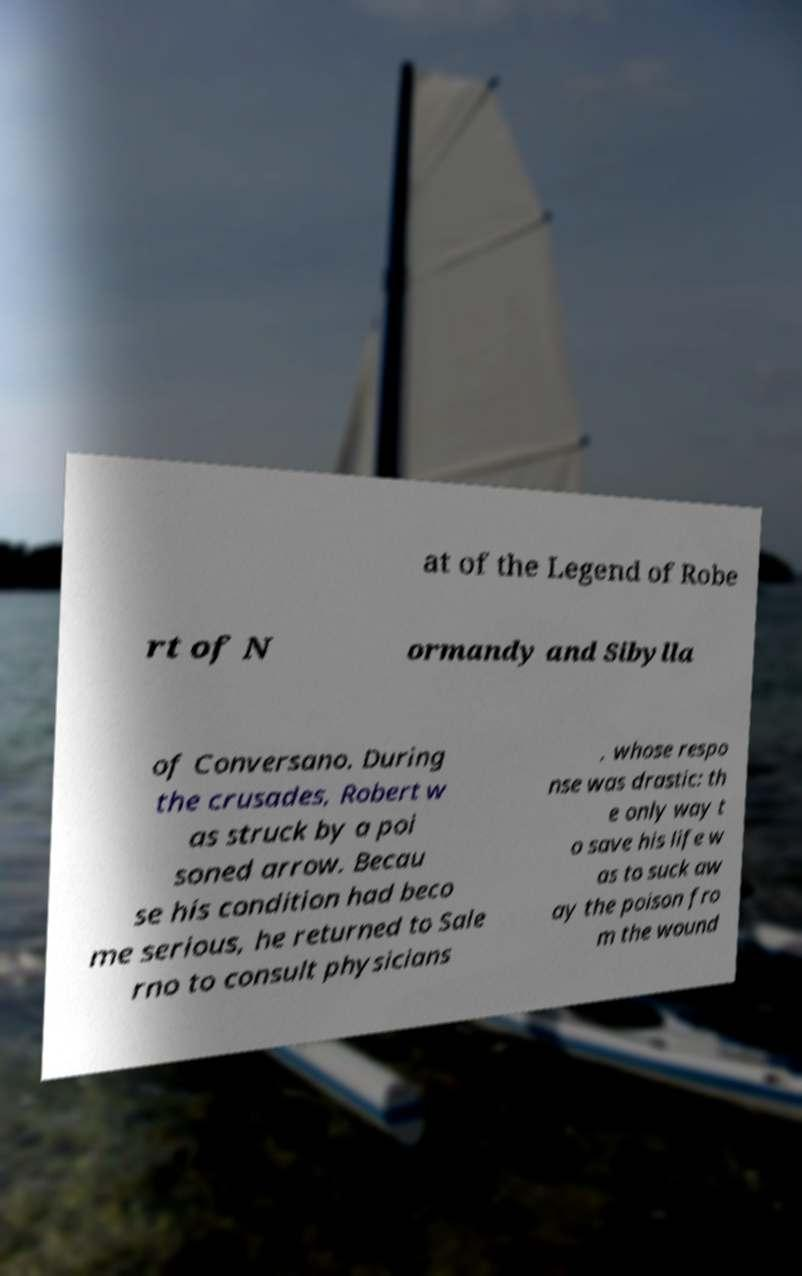Can you read and provide the text displayed in the image?This photo seems to have some interesting text. Can you extract and type it out for me? at of the Legend of Robe rt of N ormandy and Sibylla of Conversano. During the crusades, Robert w as struck by a poi soned arrow. Becau se his condition had beco me serious, he returned to Sale rno to consult physicians , whose respo nse was drastic: th e only way t o save his life w as to suck aw ay the poison fro m the wound 